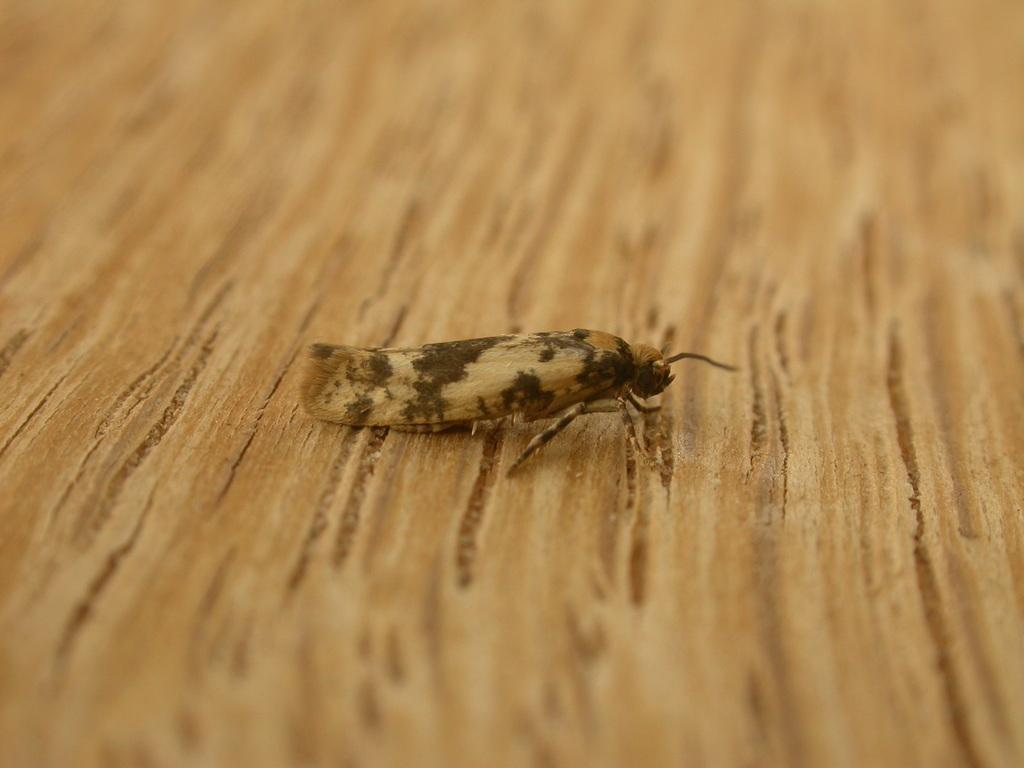Describe this image in one or two sentences. In this picture, we see an insect is on the wooden table. This picture is blurred in the background. 